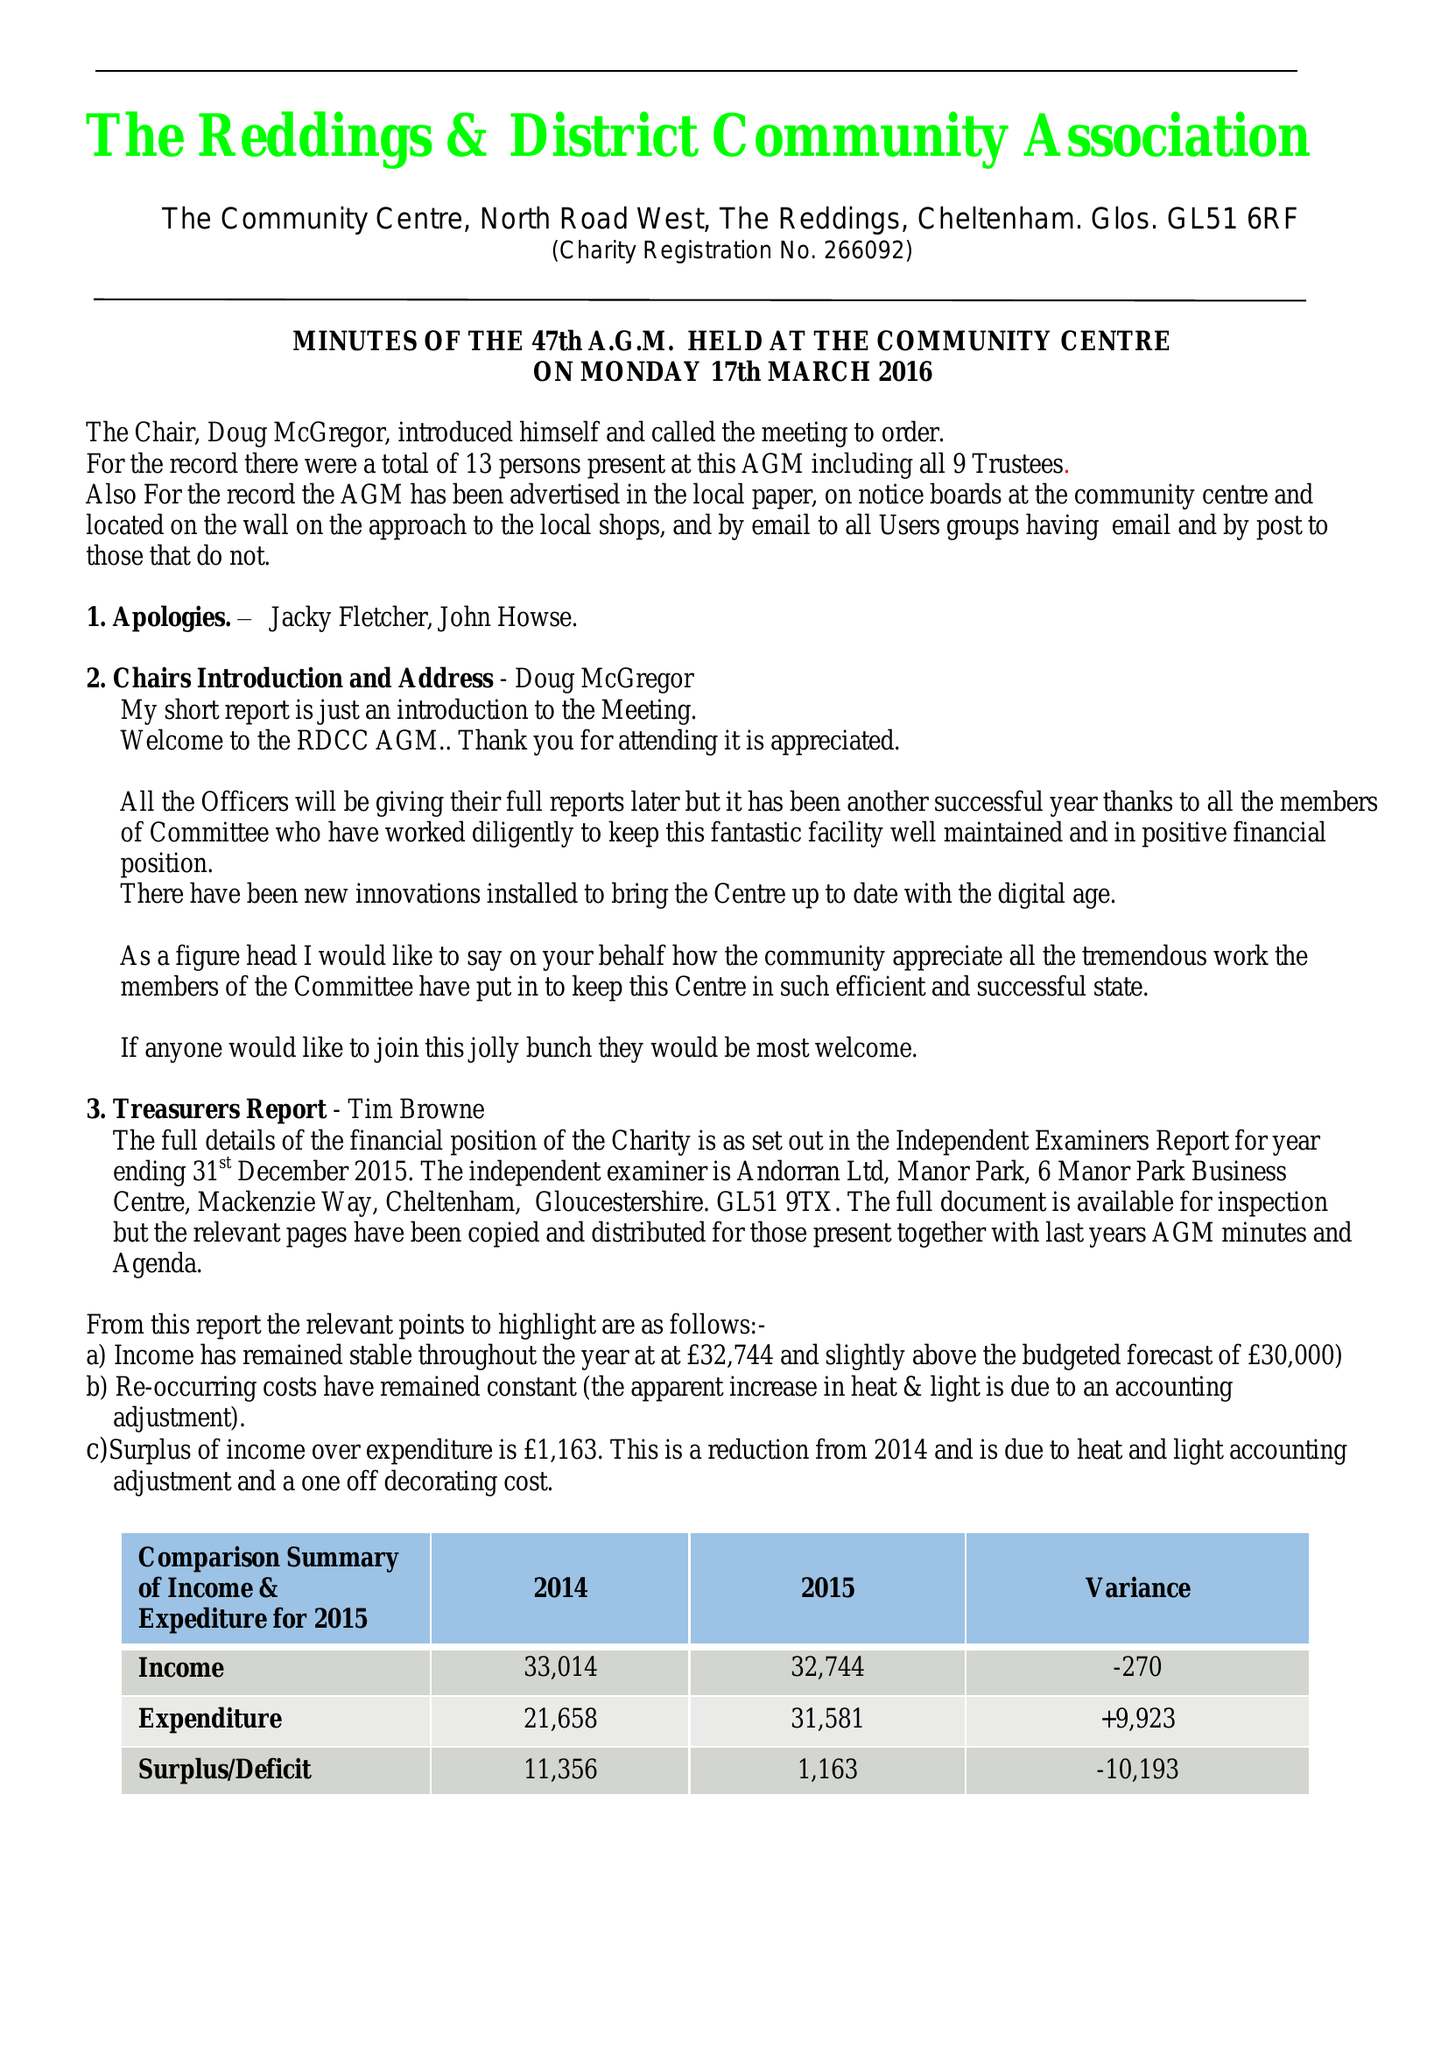What is the value for the charity_number?
Answer the question using a single word or phrase. 266092 